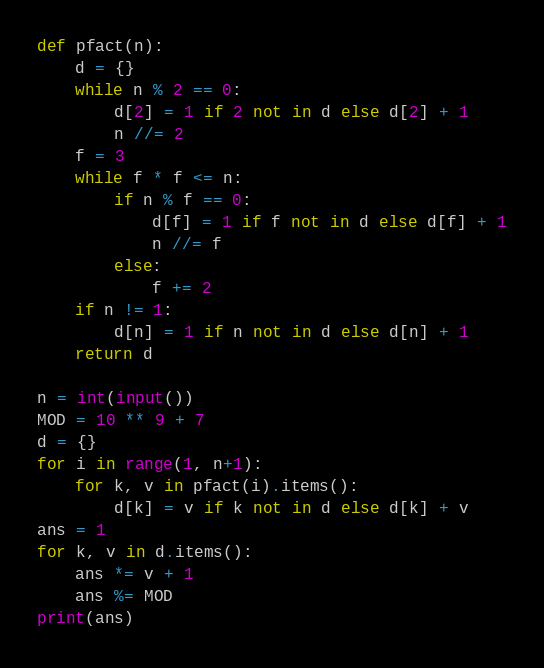<code> <loc_0><loc_0><loc_500><loc_500><_Python_>def pfact(n):
    d = {}
    while n % 2 == 0:
        d[2] = 1 if 2 not in d else d[2] + 1
        n //= 2
    f = 3
    while f * f <= n:
        if n % f == 0:
            d[f] = 1 if f not in d else d[f] + 1
            n //= f
        else:
            f += 2
    if n != 1:
        d[n] = 1 if n not in d else d[n] + 1
    return d

n = int(input())
MOD = 10 ** 9 + 7
d = {}
for i in range(1, n+1):
    for k, v in pfact(i).items():
        d[k] = v if k not in d else d[k] + v
ans = 1
for k, v in d.items():
    ans *= v + 1
    ans %= MOD
print(ans)
</code> 